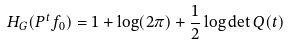<formula> <loc_0><loc_0><loc_500><loc_500>H _ { G } ( P ^ { t } f _ { 0 } ) = 1 + \log ( 2 \pi ) + \frac { 1 } { 2 } \log \det Q ( t )</formula> 